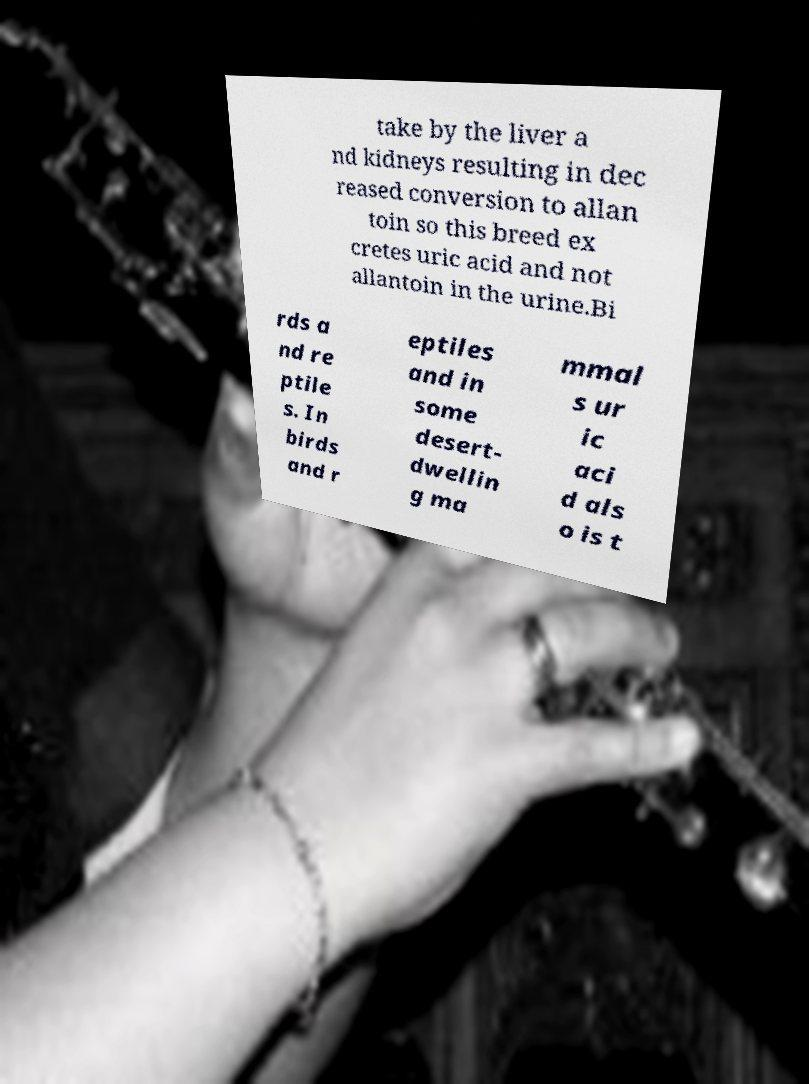Could you assist in decoding the text presented in this image and type it out clearly? take by the liver a nd kidneys resulting in dec reased conversion to allan toin so this breed ex cretes uric acid and not allantoin in the urine.Bi rds a nd re ptile s. In birds and r eptiles and in some desert- dwellin g ma mmal s ur ic aci d als o is t 